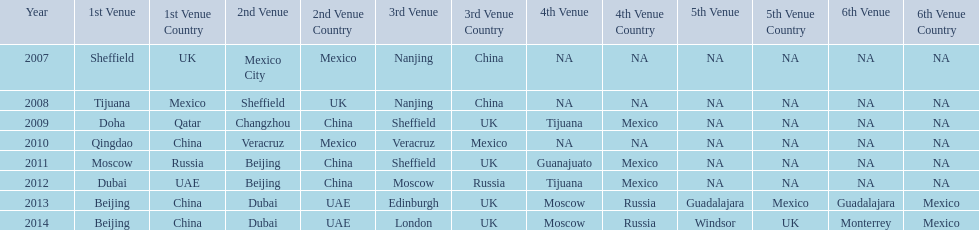Did 2007 or 2012 have a higher count of venues? 2012. 